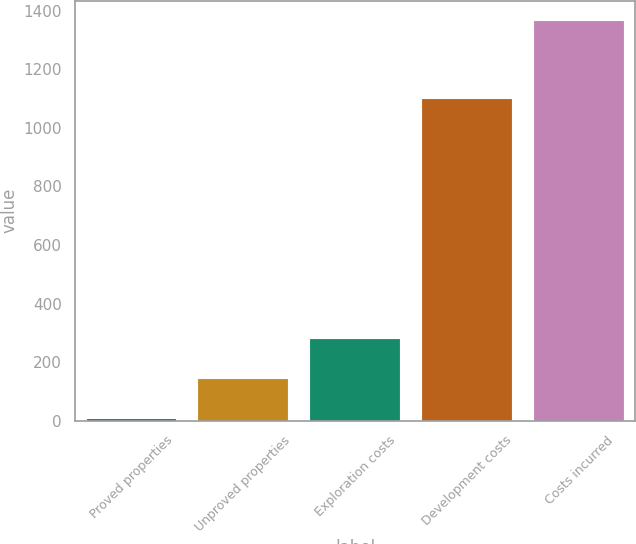Convert chart to OTSL. <chart><loc_0><loc_0><loc_500><loc_500><bar_chart><fcel>Proved properties<fcel>Unproved properties<fcel>Exploration costs<fcel>Development costs<fcel>Costs incurred<nl><fcel>7<fcel>142.8<fcel>278.6<fcel>1098<fcel>1365<nl></chart> 